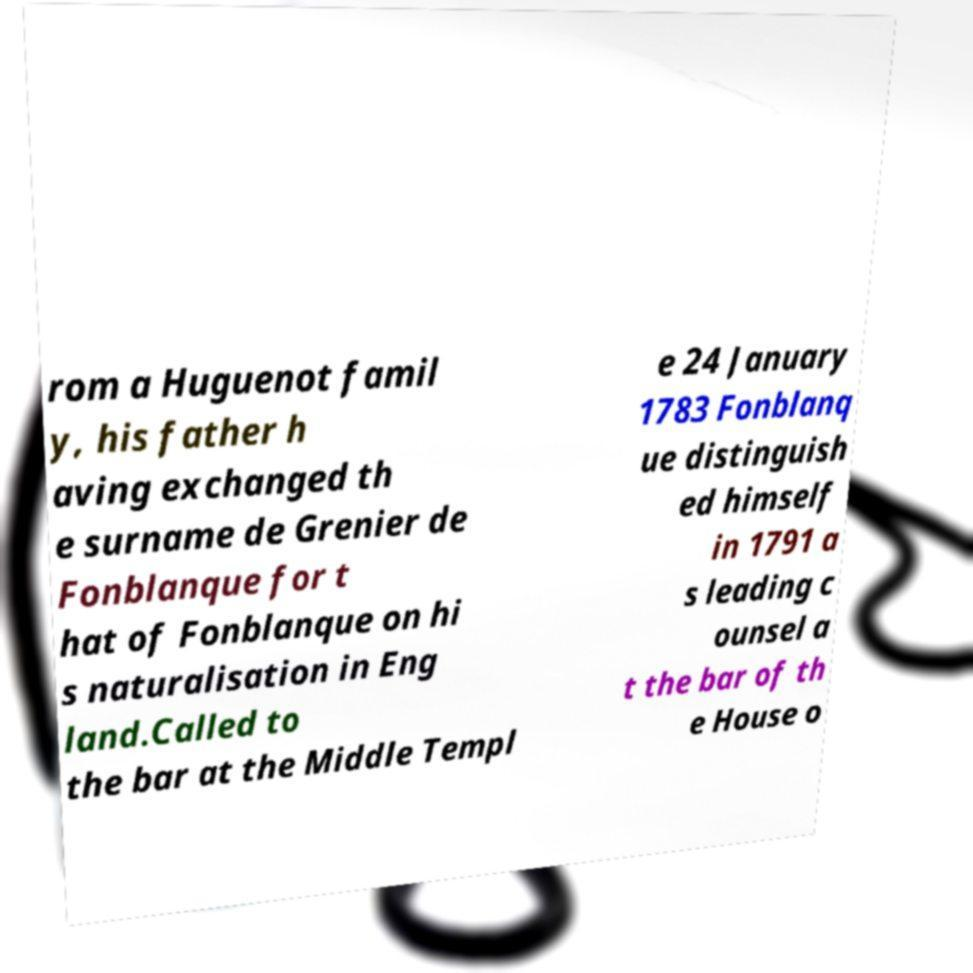There's text embedded in this image that I need extracted. Can you transcribe it verbatim? rom a Huguenot famil y, his father h aving exchanged th e surname de Grenier de Fonblanque for t hat of Fonblanque on hi s naturalisation in Eng land.Called to the bar at the Middle Templ e 24 January 1783 Fonblanq ue distinguish ed himself in 1791 a s leading c ounsel a t the bar of th e House o 